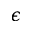Convert formula to latex. <formula><loc_0><loc_0><loc_500><loc_500>\epsilon</formula> 